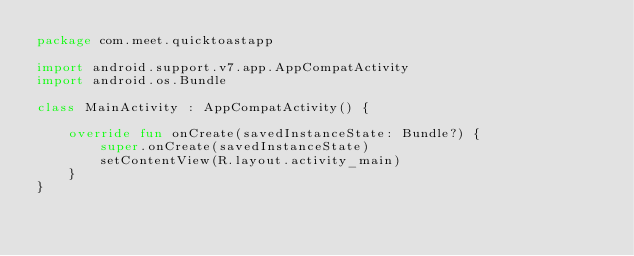Convert code to text. <code><loc_0><loc_0><loc_500><loc_500><_Kotlin_>package com.meet.quicktoastapp

import android.support.v7.app.AppCompatActivity
import android.os.Bundle

class MainActivity : AppCompatActivity() {

    override fun onCreate(savedInstanceState: Bundle?) {
        super.onCreate(savedInstanceState)
        setContentView(R.layout.activity_main)
    }
}
</code> 